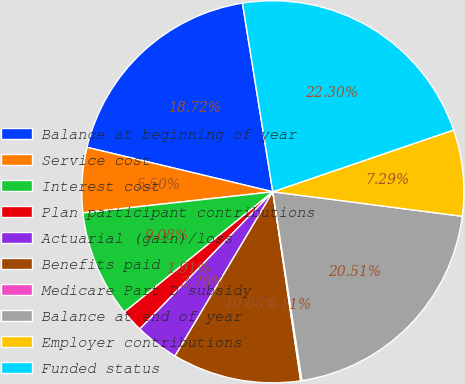Convert chart. <chart><loc_0><loc_0><loc_500><loc_500><pie_chart><fcel>Balance at beginning of year<fcel>Service cost<fcel>Interest cost<fcel>Plan participant contributions<fcel>Actuarial (gain)/loss<fcel>Benefits paid<fcel>Medicare Part D subsidy<fcel>Balance at end of year<fcel>Employer contributions<fcel>Funded status<nl><fcel>18.72%<fcel>5.5%<fcel>9.08%<fcel>1.91%<fcel>3.7%<fcel>10.88%<fcel>0.11%<fcel>20.51%<fcel>7.29%<fcel>22.3%<nl></chart> 